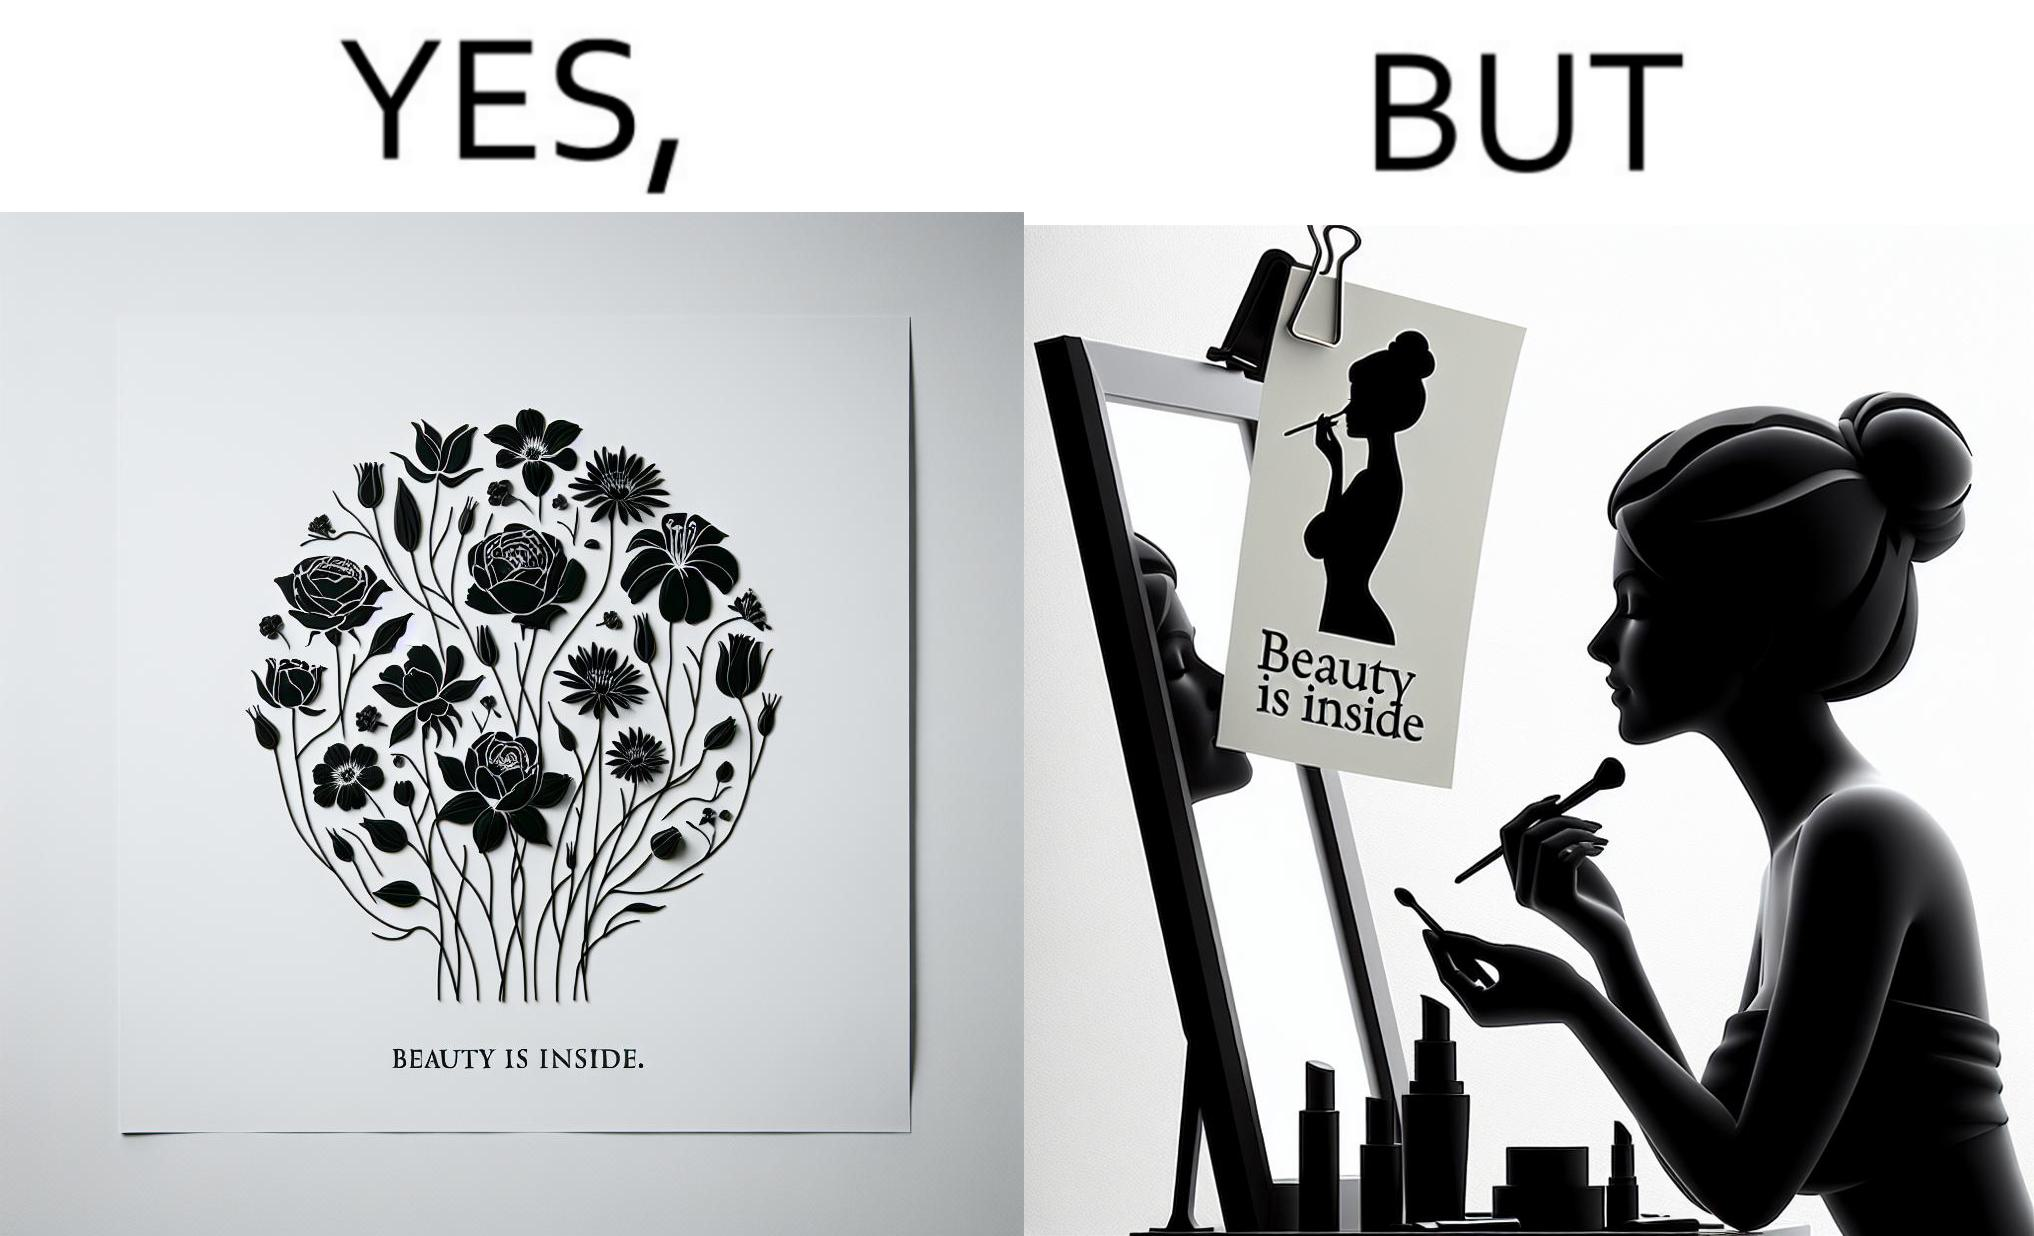Is this a satirical image? Yes, this image is satirical. 